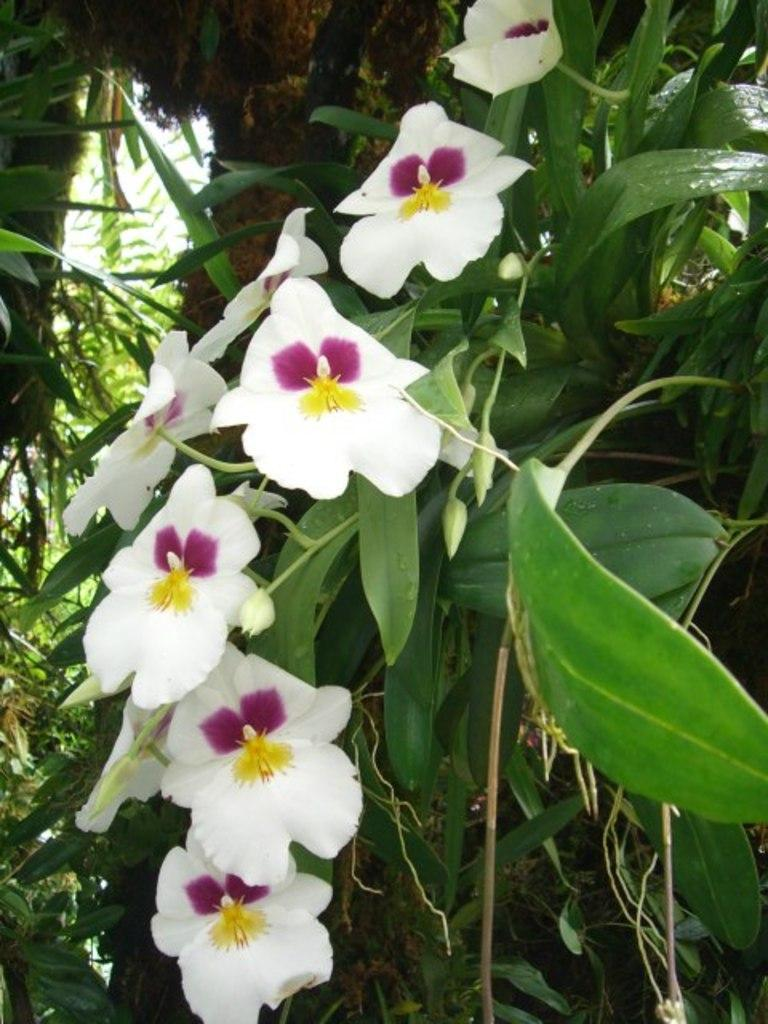What type of plant can be seen in the image? There is a tree in the image. What features can be observed on the tree? The tree has leaves and flowers. What color are the flowers on the tree? The flowers on the tree are white in color. What type of toothbrush is hanging from the tree in the image? There is no toothbrush present in the image; it features a tree with leaves and white flowers. 